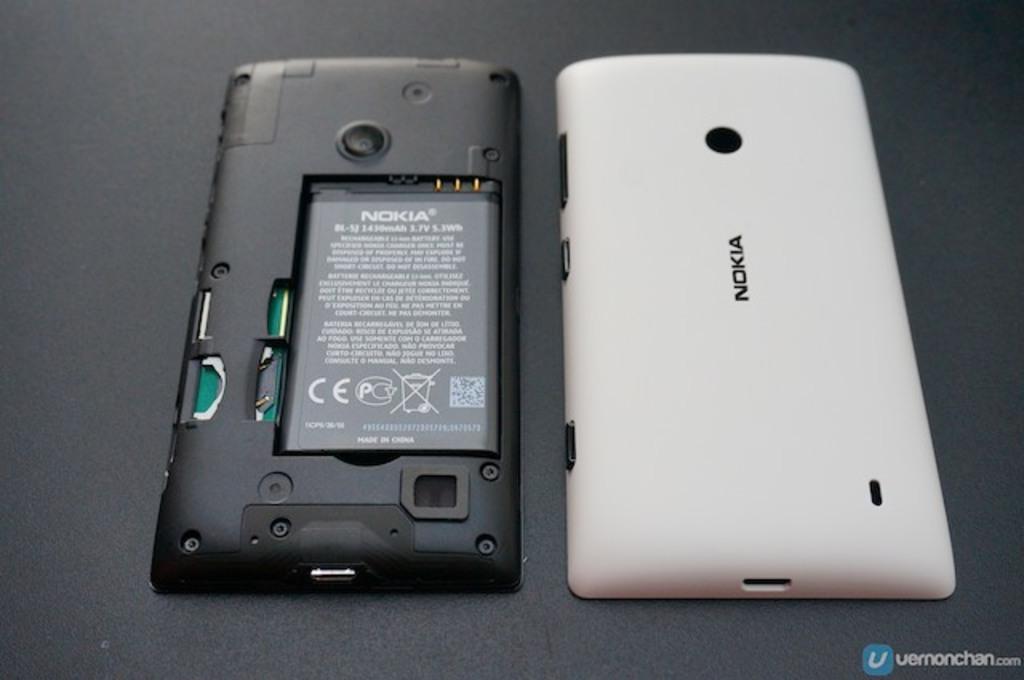Who is the manufacturer of this phone?
Offer a very short reply. Nokia. In what country was the battery made?
Your answer should be very brief. China. 